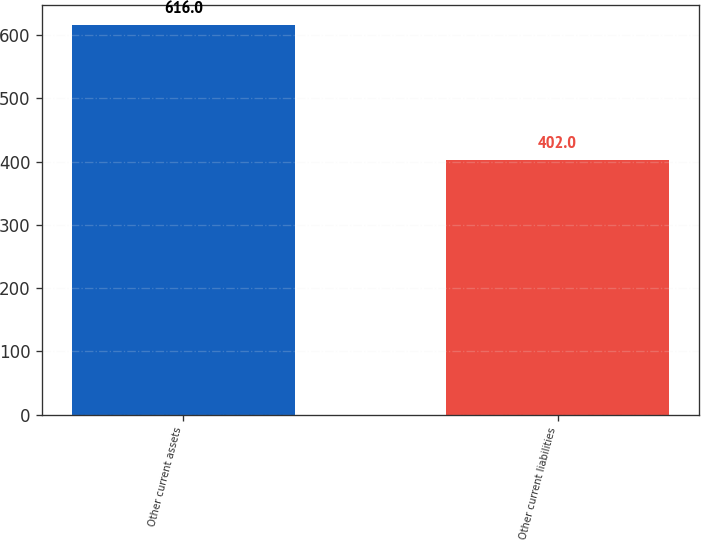<chart> <loc_0><loc_0><loc_500><loc_500><bar_chart><fcel>Other current assets<fcel>Other current liabilities<nl><fcel>616<fcel>402<nl></chart> 